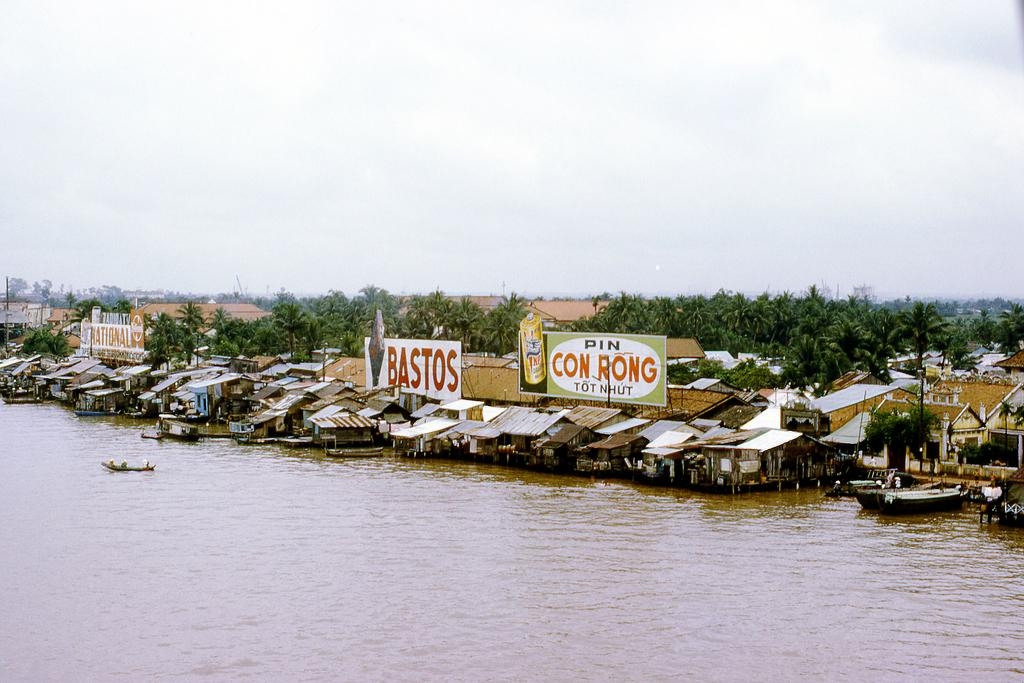What is the main feature of the image? The main feature of the image is water. What can be seen floating on the water? There are boats in the image. What structures are visible near the water? There are houses in the image. the image. What type of vegetation is present in the image? There are trees in the image. What objects are placed near the water? There are boards in the image. What is visible in the background of the image? The sky is visible in the background of the image. Can you hear the parcel crying in the image? There is no parcel or crying sound present in the image. 